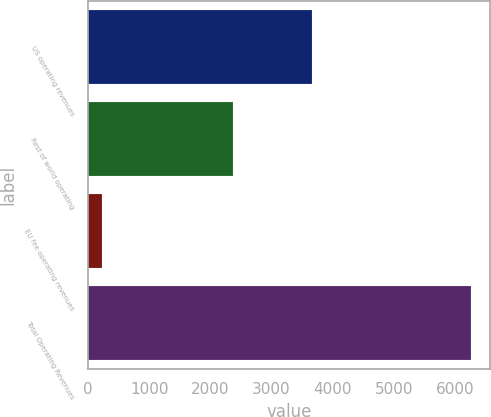Convert chart. <chart><loc_0><loc_0><loc_500><loc_500><bar_chart><fcel>US operating revenues<fcel>Rest of world operating<fcel>EU fee operating revenues<fcel>Total Operating Revenues<nl><fcel>3664<fcel>2378<fcel>221<fcel>6263<nl></chart> 